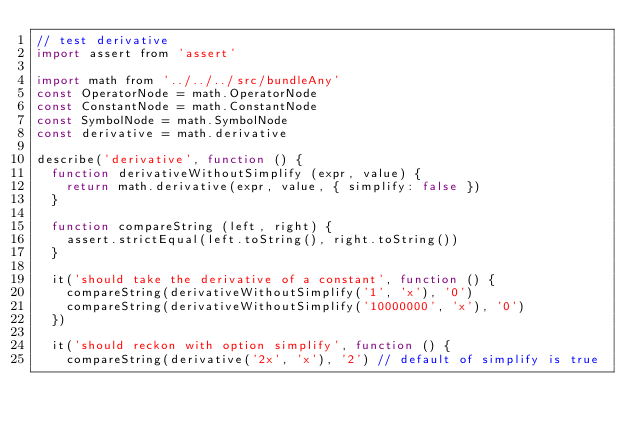<code> <loc_0><loc_0><loc_500><loc_500><_JavaScript_>// test derivative
import assert from 'assert'

import math from '../../../src/bundleAny'
const OperatorNode = math.OperatorNode
const ConstantNode = math.ConstantNode
const SymbolNode = math.SymbolNode
const derivative = math.derivative

describe('derivative', function () {
  function derivativeWithoutSimplify (expr, value) {
    return math.derivative(expr, value, { simplify: false })
  }

  function compareString (left, right) {
    assert.strictEqual(left.toString(), right.toString())
  }

  it('should take the derivative of a constant', function () {
    compareString(derivativeWithoutSimplify('1', 'x'), '0')
    compareString(derivativeWithoutSimplify('10000000', 'x'), '0')
  })

  it('should reckon with option simplify', function () {
    compareString(derivative('2x', 'x'), '2') // default of simplify is true</code> 